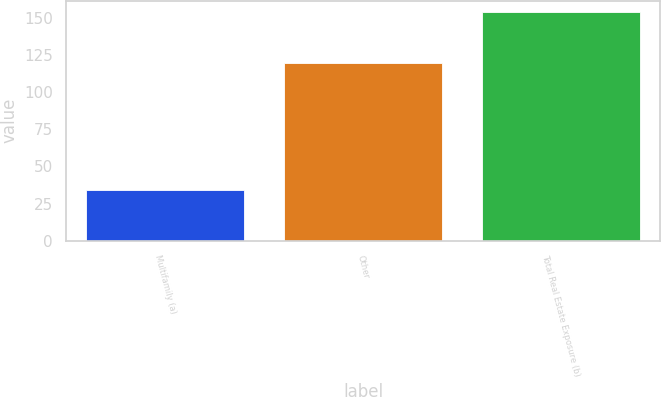Convert chart to OTSL. <chart><loc_0><loc_0><loc_500><loc_500><bar_chart><fcel>Multifamily (a)<fcel>Other<fcel>Total Real Estate Exposure (b)<nl><fcel>34<fcel>120<fcel>154<nl></chart> 